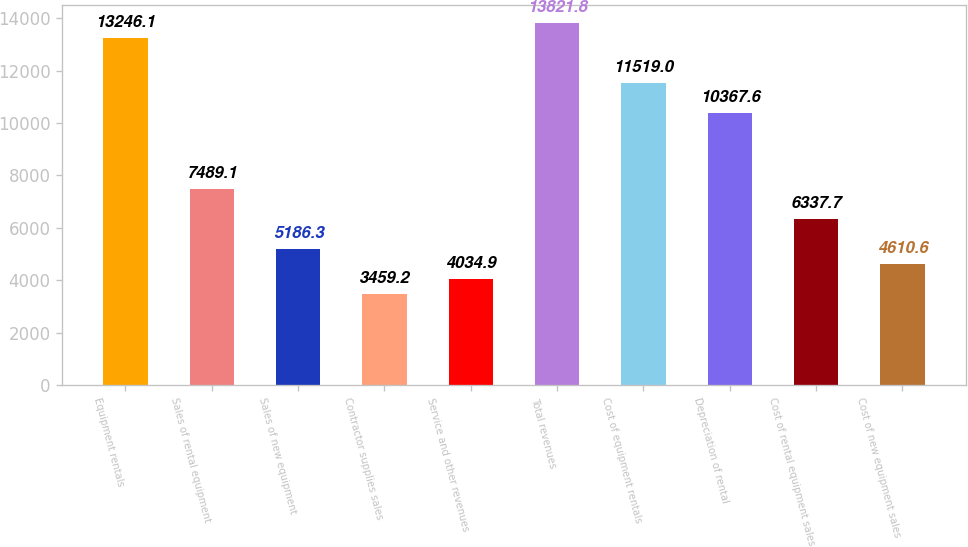Convert chart. <chart><loc_0><loc_0><loc_500><loc_500><bar_chart><fcel>Equipment rentals<fcel>Sales of rental equipment<fcel>Sales of new equipment<fcel>Contractor supplies sales<fcel>Service and other revenues<fcel>Total revenues<fcel>Cost of equipment rentals<fcel>Depreciation of rental<fcel>Cost of rental equipment sales<fcel>Cost of new equipment sales<nl><fcel>13246.1<fcel>7489.1<fcel>5186.3<fcel>3459.2<fcel>4034.9<fcel>13821.8<fcel>11519<fcel>10367.6<fcel>6337.7<fcel>4610.6<nl></chart> 